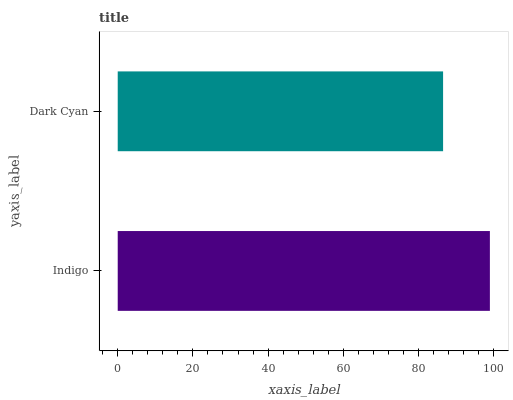Is Dark Cyan the minimum?
Answer yes or no. Yes. Is Indigo the maximum?
Answer yes or no. Yes. Is Dark Cyan the maximum?
Answer yes or no. No. Is Indigo greater than Dark Cyan?
Answer yes or no. Yes. Is Dark Cyan less than Indigo?
Answer yes or no. Yes. Is Dark Cyan greater than Indigo?
Answer yes or no. No. Is Indigo less than Dark Cyan?
Answer yes or no. No. Is Indigo the high median?
Answer yes or no. Yes. Is Dark Cyan the low median?
Answer yes or no. Yes. Is Dark Cyan the high median?
Answer yes or no. No. Is Indigo the low median?
Answer yes or no. No. 